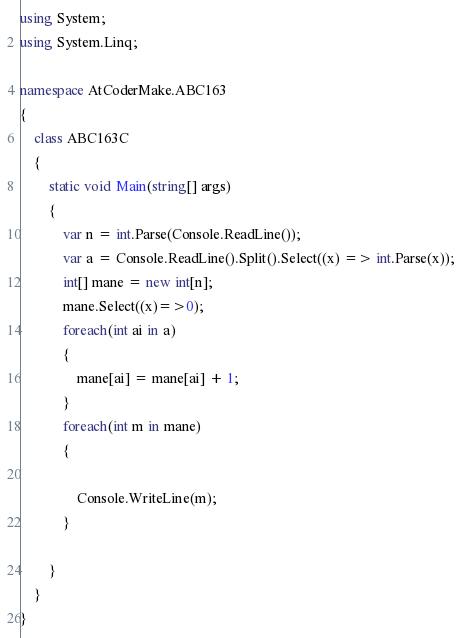<code> <loc_0><loc_0><loc_500><loc_500><_C#_>using System;
using System.Linq;

namespace AtCoderMake.ABC163
{
    class ABC163C
    {
        static void Main(string[] args)
        {
            var n = int.Parse(Console.ReadLine());
            var a = Console.ReadLine().Split().Select((x) => int.Parse(x));
            int[] mane = new int[n];
            mane.Select((x)=>0);
            foreach(int ai in a)
            {
                mane[ai] = mane[ai] + 1;
            }
            foreach(int m in mane)
            {

                Console.WriteLine(m);
            }

        }
    }
}
</code> 